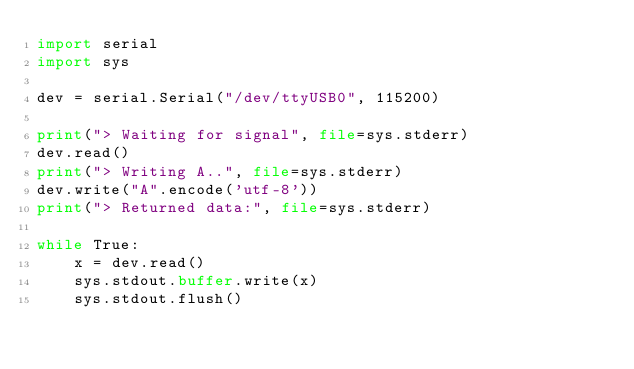Convert code to text. <code><loc_0><loc_0><loc_500><loc_500><_Python_>import serial
import sys

dev = serial.Serial("/dev/ttyUSB0", 115200)

print("> Waiting for signal", file=sys.stderr)
dev.read()
print("> Writing A..", file=sys.stderr)
dev.write("A".encode('utf-8'))
print("> Returned data:", file=sys.stderr)

while True:
    x = dev.read()
    sys.stdout.buffer.write(x)
    sys.stdout.flush()
</code> 